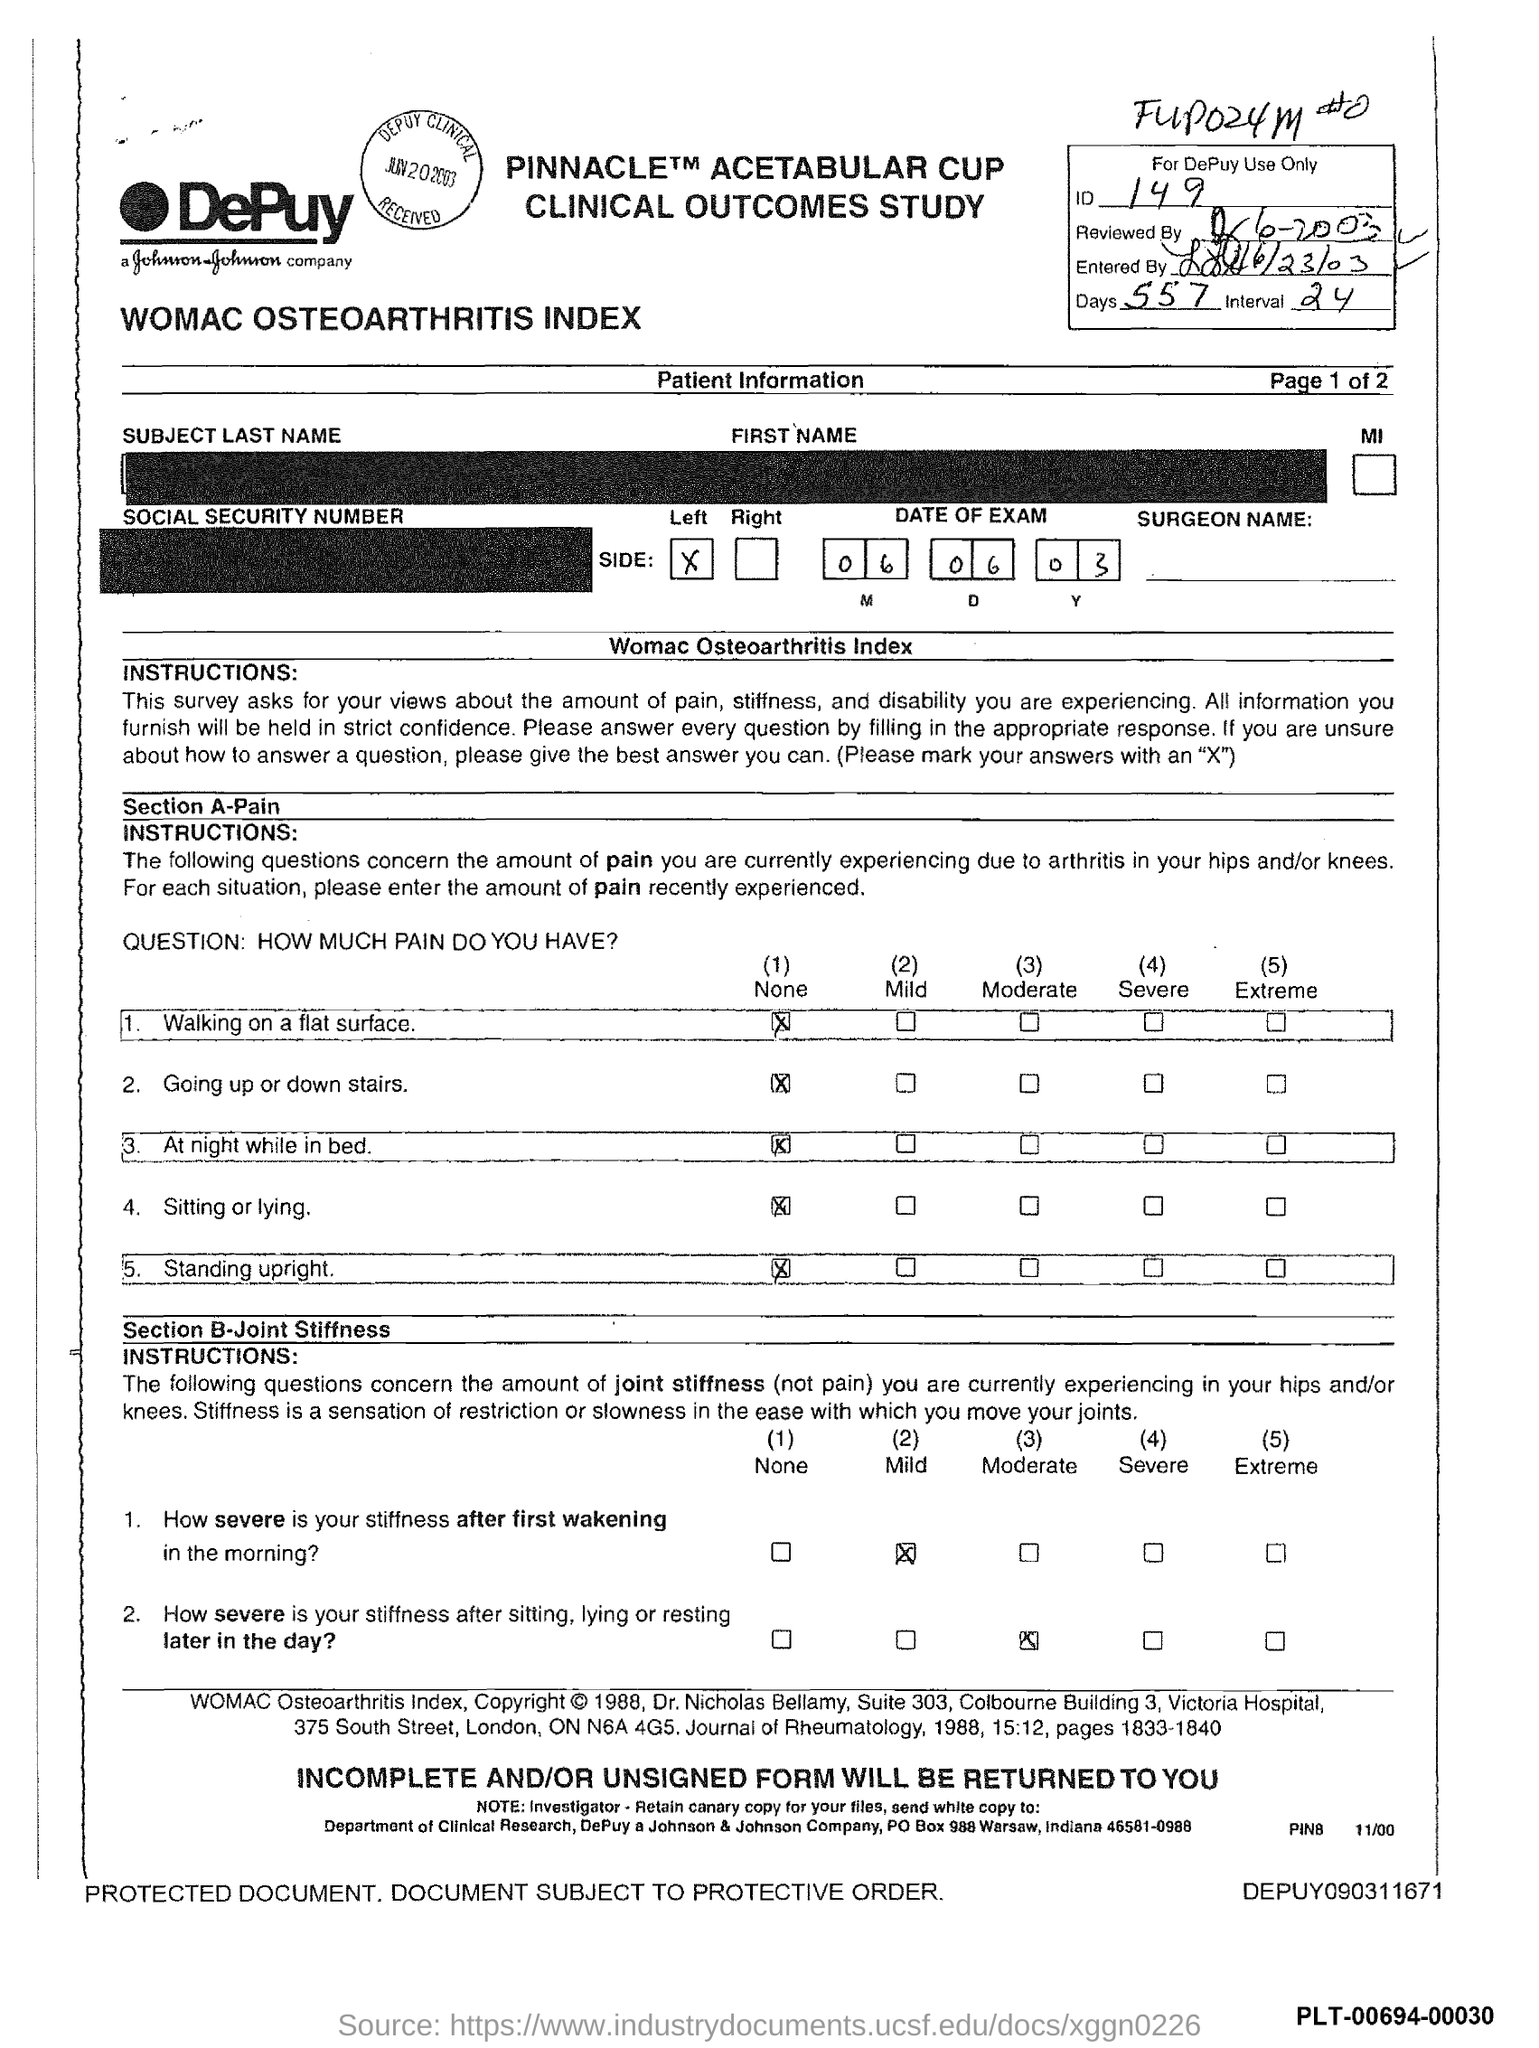Highlight a few significant elements in this photo. The interval mentioned in the form is 24.. There are 557 days given in the form. The exam date, as specified in the form, is June 6, 2003. 